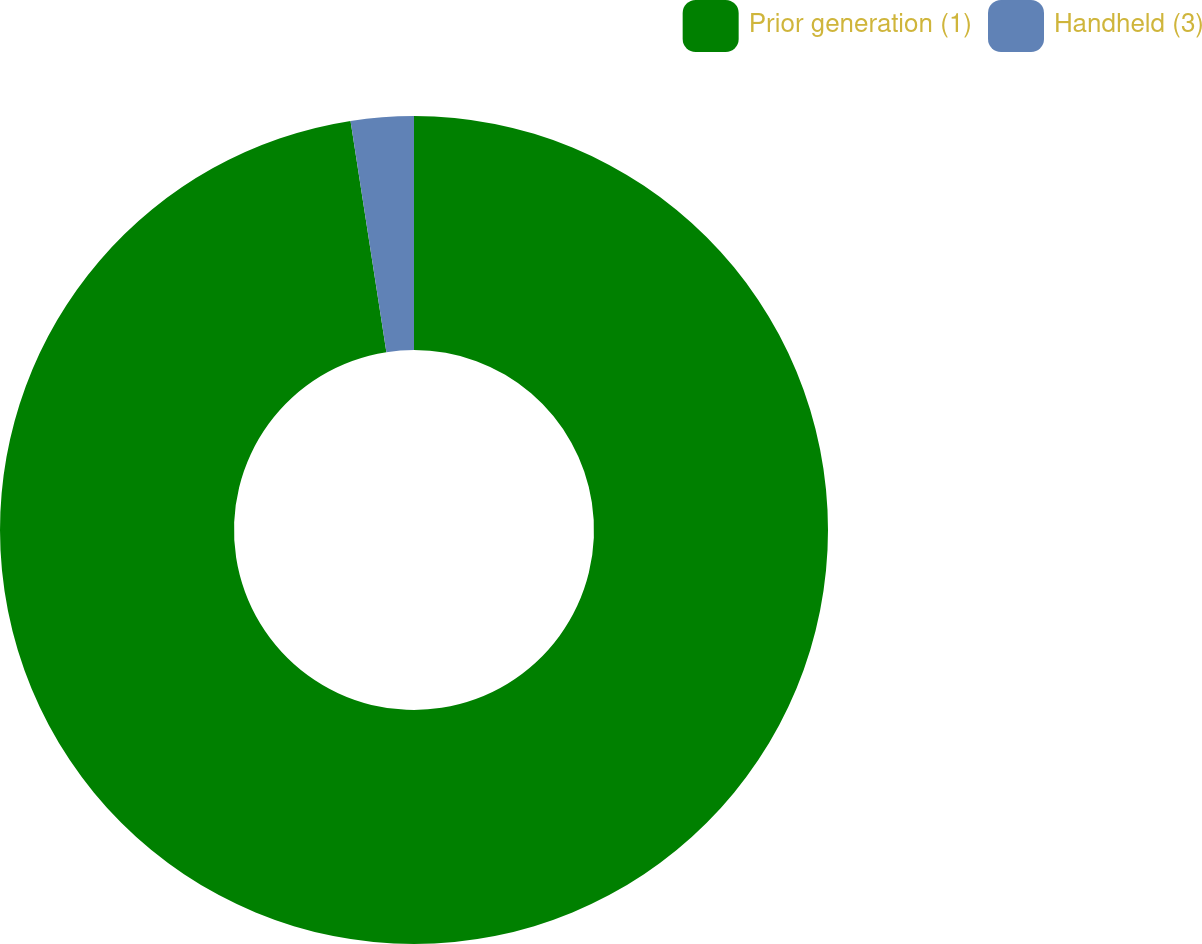Convert chart. <chart><loc_0><loc_0><loc_500><loc_500><pie_chart><fcel>Prior generation (1)<fcel>Handheld (3)<nl><fcel>97.55%<fcel>2.45%<nl></chart> 